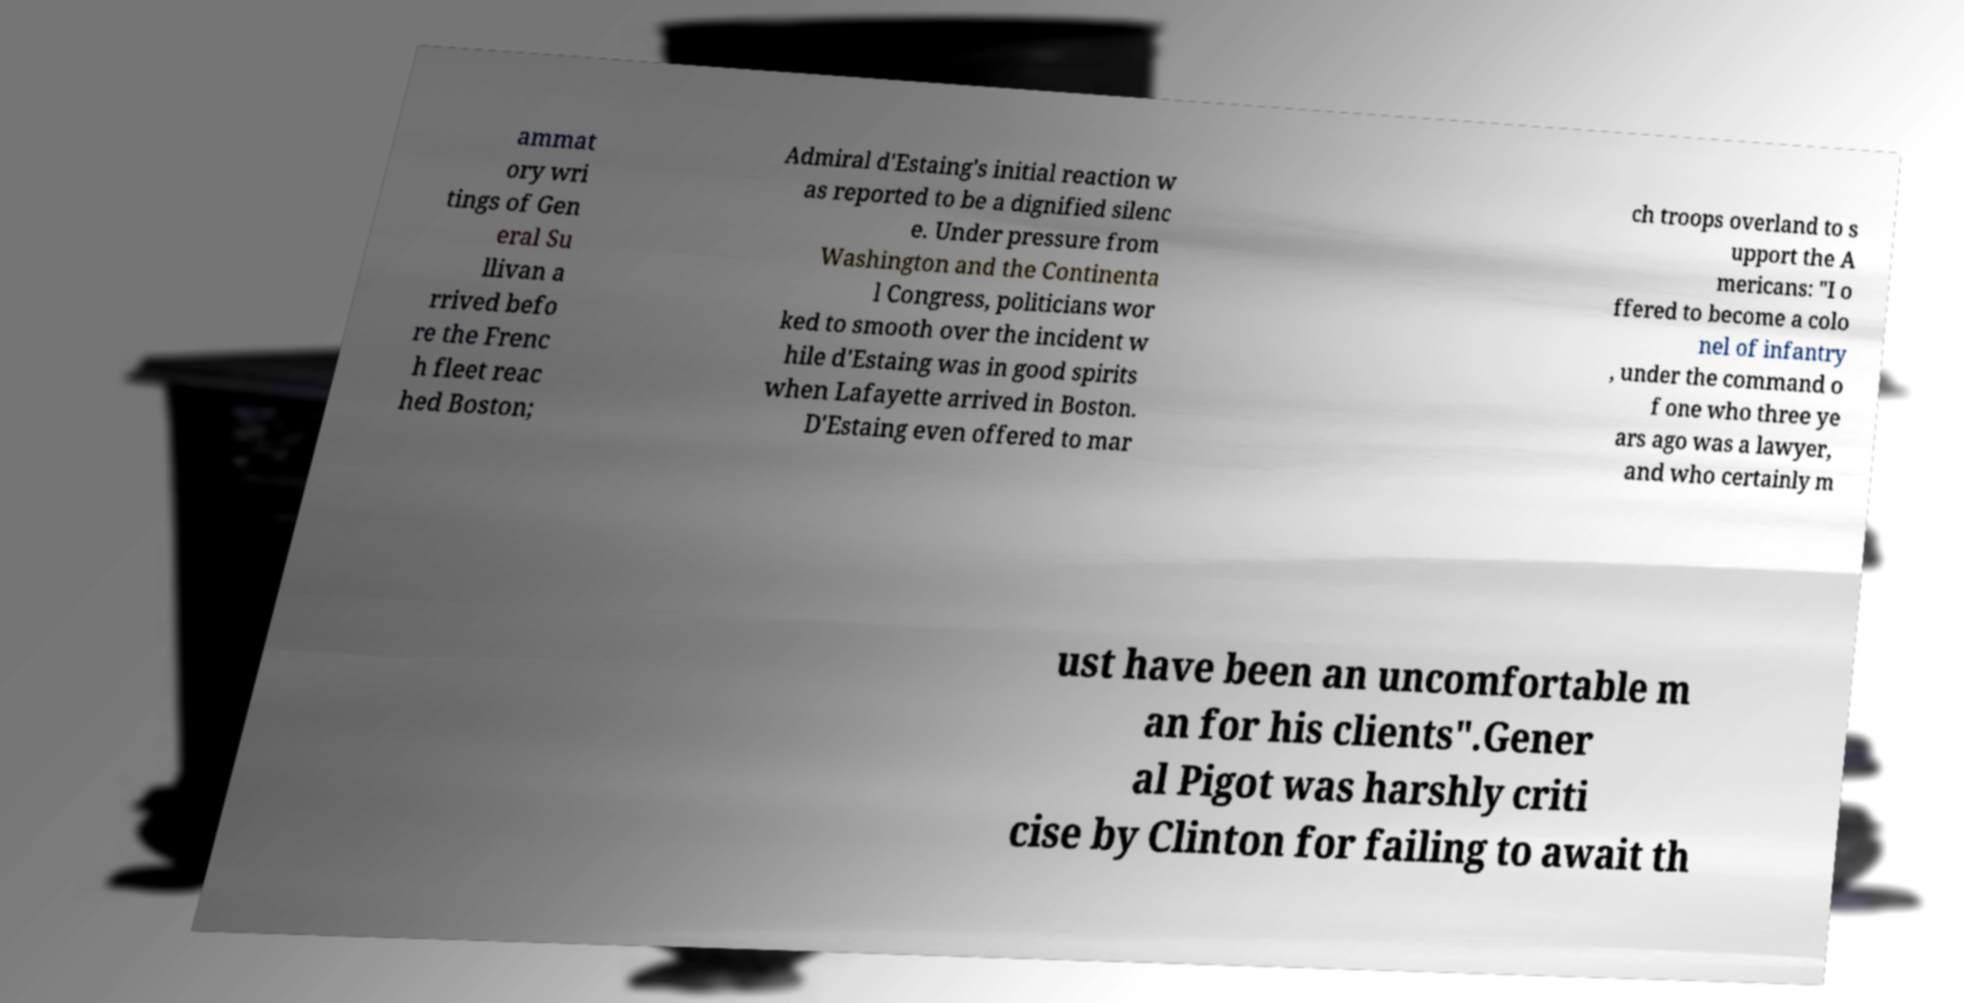Could you extract and type out the text from this image? ammat ory wri tings of Gen eral Su llivan a rrived befo re the Frenc h fleet reac hed Boston; Admiral d'Estaing's initial reaction w as reported to be a dignified silenc e. Under pressure from Washington and the Continenta l Congress, politicians wor ked to smooth over the incident w hile d'Estaing was in good spirits when Lafayette arrived in Boston. D'Estaing even offered to mar ch troops overland to s upport the A mericans: "I o ffered to become a colo nel of infantry , under the command o f one who three ye ars ago was a lawyer, and who certainly m ust have been an uncomfortable m an for his clients".Gener al Pigot was harshly criti cise by Clinton for failing to await th 